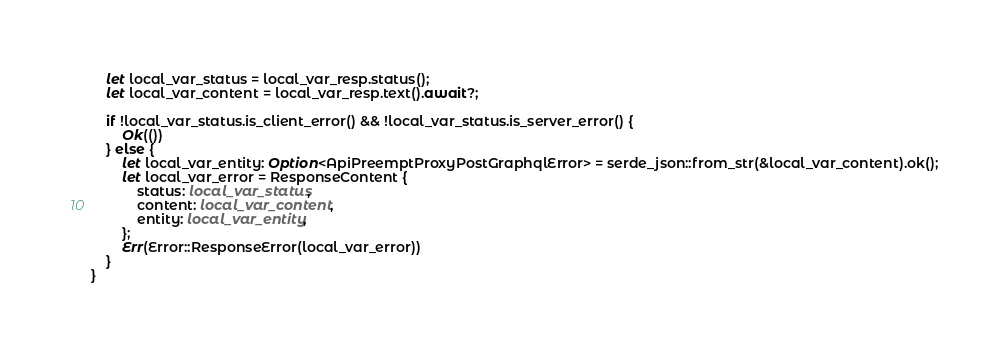Convert code to text. <code><loc_0><loc_0><loc_500><loc_500><_Rust_>
    let local_var_status = local_var_resp.status();
    let local_var_content = local_var_resp.text().await?;

    if !local_var_status.is_client_error() && !local_var_status.is_server_error() {
        Ok(())
    } else {
        let local_var_entity: Option<ApiPreemptProxyPostGraphqlError> = serde_json::from_str(&local_var_content).ok();
        let local_var_error = ResponseContent {
            status: local_var_status,
            content: local_var_content,
            entity: local_var_entity,
        };
        Err(Error::ResponseError(local_var_error))
    }
}
</code> 